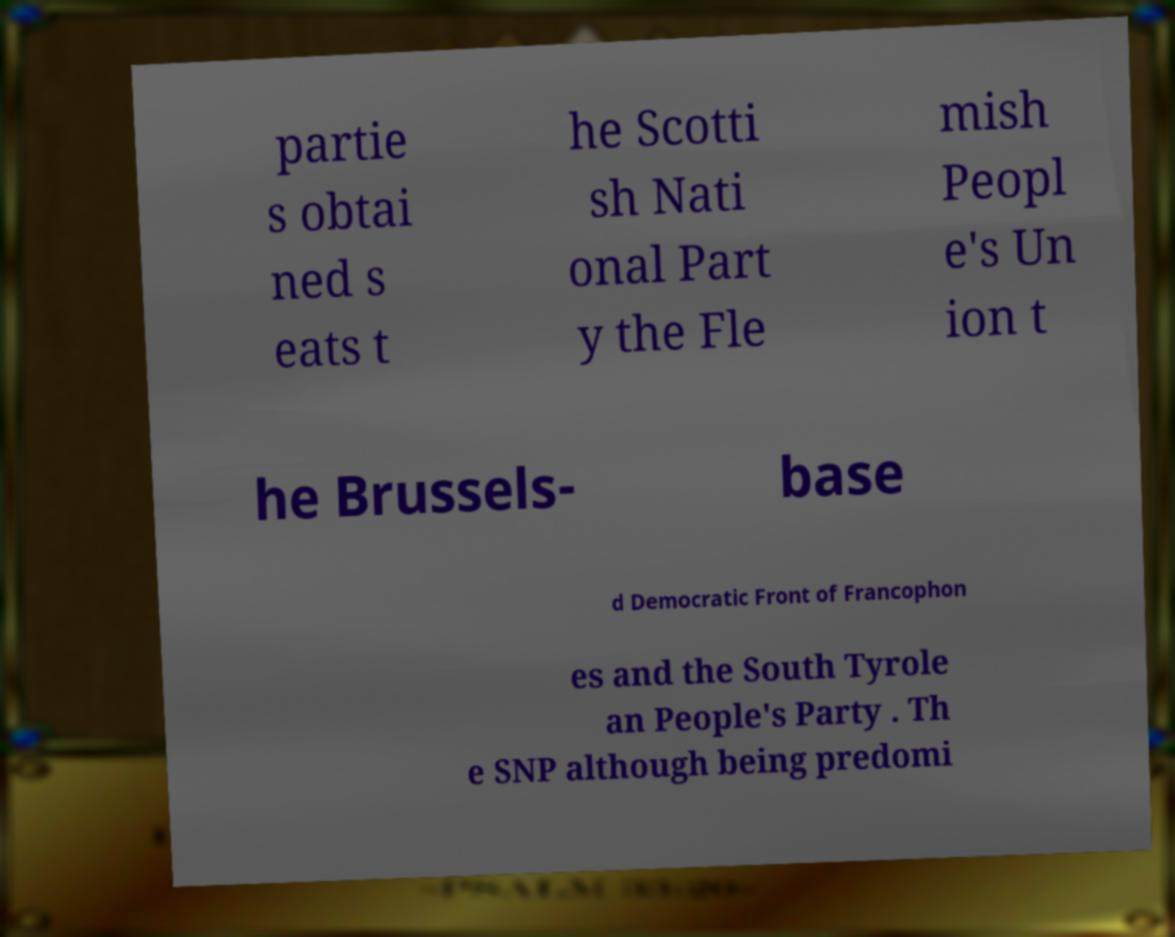Could you assist in decoding the text presented in this image and type it out clearly? partie s obtai ned s eats t he Scotti sh Nati onal Part y the Fle mish Peopl e's Un ion t he Brussels- base d Democratic Front of Francophon es and the South Tyrole an People's Party . Th e SNP although being predomi 